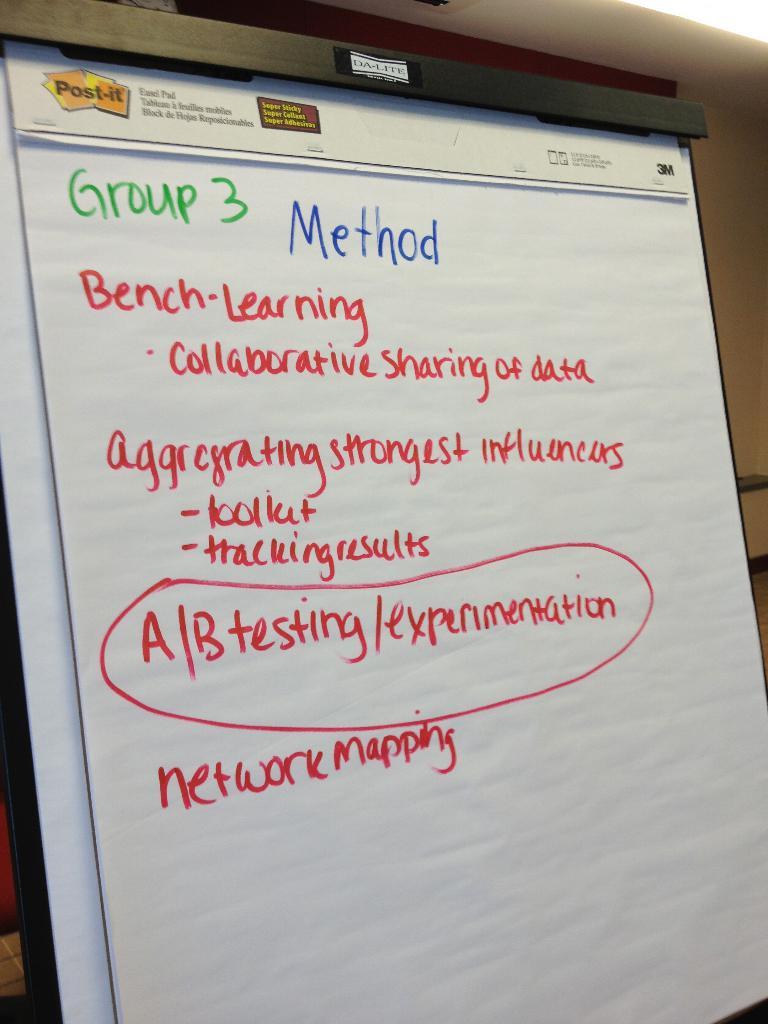What is the group number?
Your response must be concise. 3. 